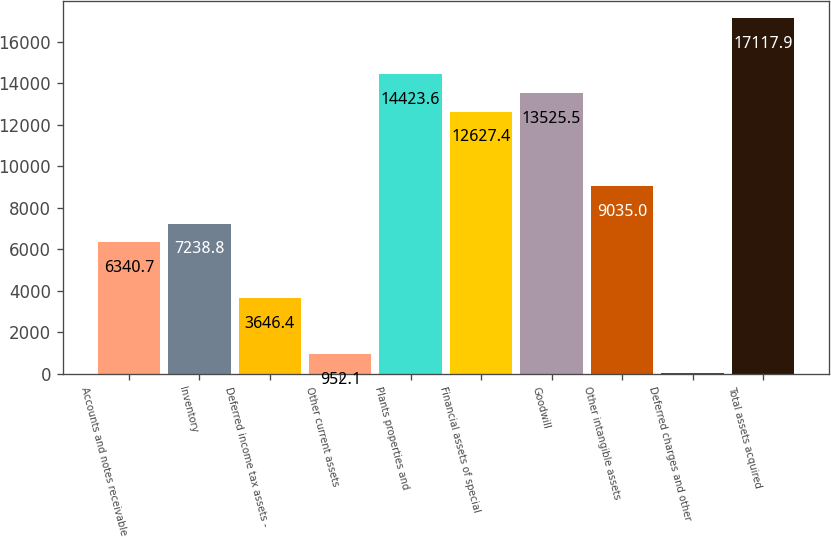Convert chart. <chart><loc_0><loc_0><loc_500><loc_500><bar_chart><fcel>Accounts and notes receivable<fcel>Inventory<fcel>Deferred income tax assets -<fcel>Other current assets<fcel>Plants properties and<fcel>Financial assets of special<fcel>Goodwill<fcel>Other intangible assets<fcel>Deferred charges and other<fcel>Total assets acquired<nl><fcel>6340.7<fcel>7238.8<fcel>3646.4<fcel>952.1<fcel>14423.6<fcel>12627.4<fcel>13525.5<fcel>9035<fcel>54<fcel>17117.9<nl></chart> 